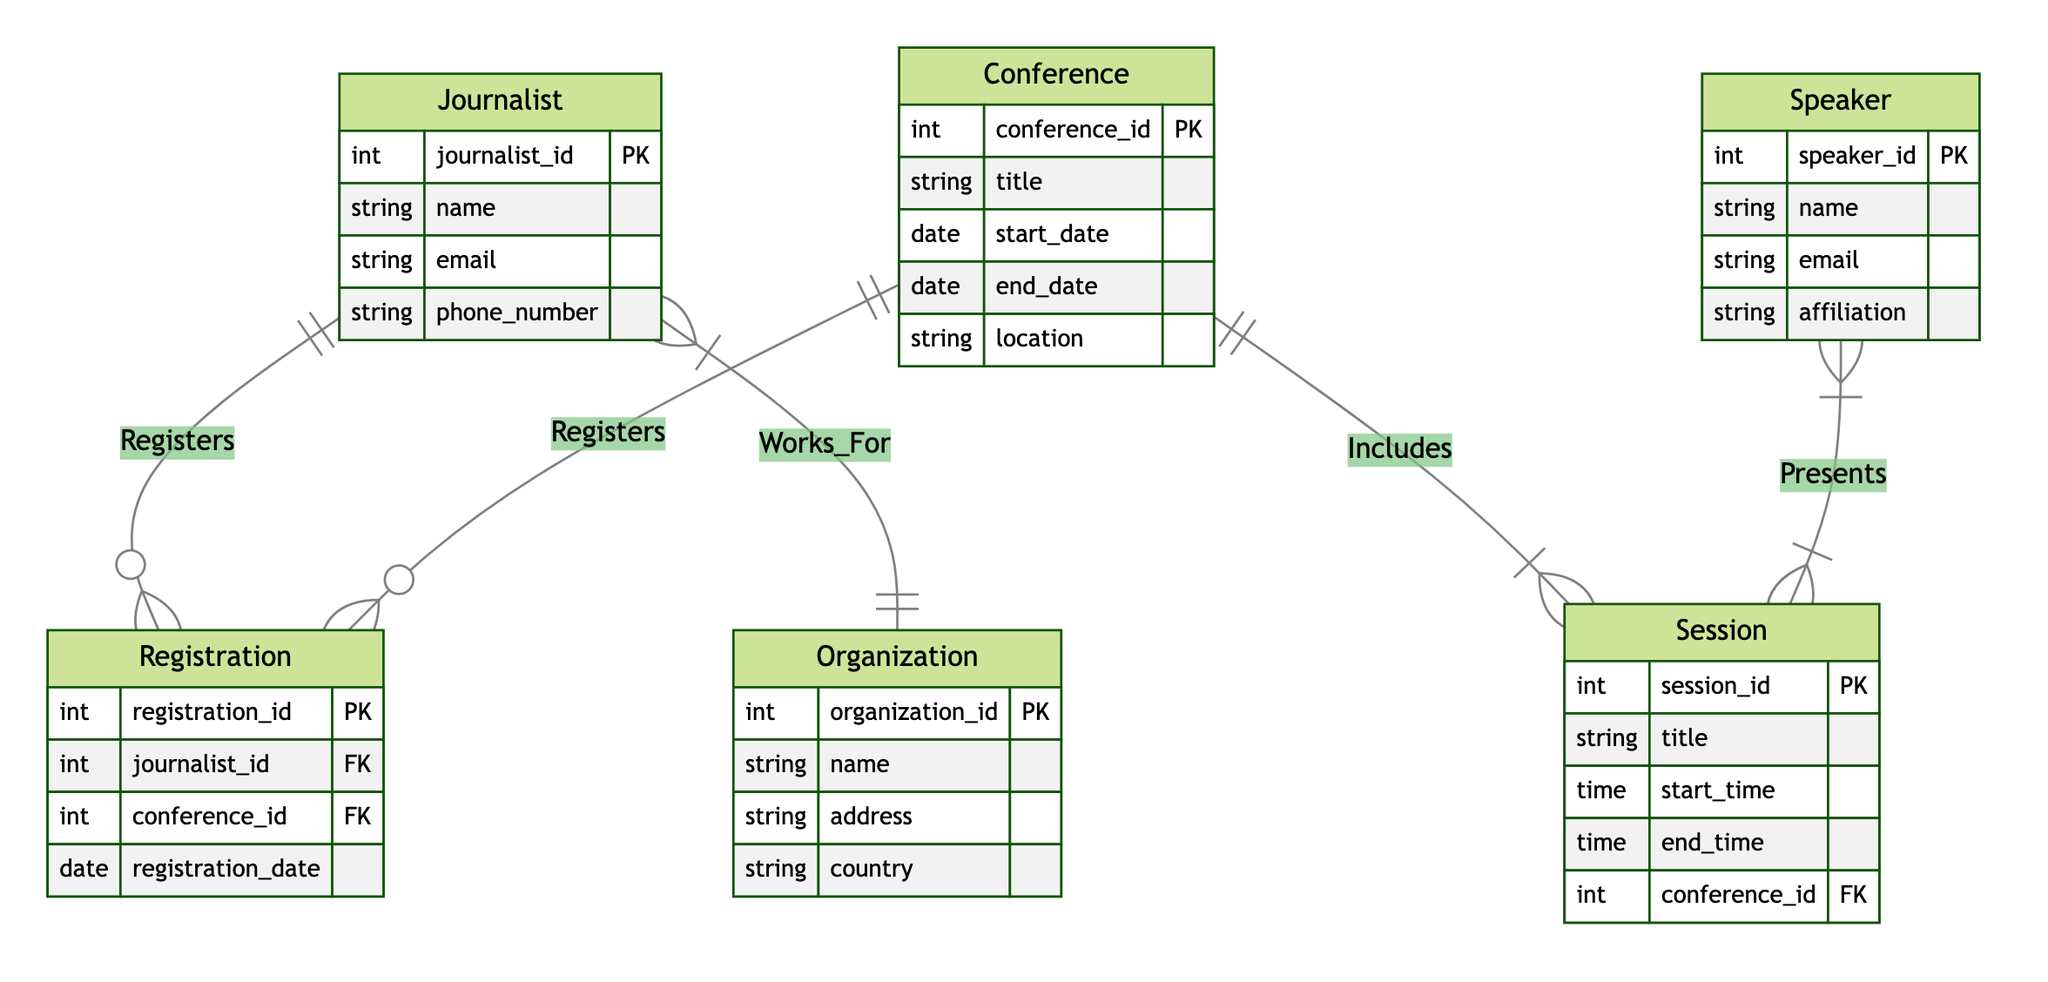What is the primary key of the Journalist entity? The primary key of the Journalist entity is journalist_id, which uniquely identifies each journalist in the system.
Answer: journalist_id How many attributes does the Conference entity have? The Conference entity has five attributes: conference_id, title, start_date, end_date, and location.
Answer: five What relationship exists between the Journalist and Conference entities? The relationship between the Journalist and Conference entities is titled "Registers," and it is a many-to-many relationship, indicating that multiple journalists can register for multiple conferences.
Answer: Registers How many sessions can a Conference include? A Conference can include one or more sessions, as indicated by the one-to-many relationship labeled "Includes" between Conference and Session.
Answer: one or more Which entity is the Speaker associated with in this diagram? The Speaker entity is associated with the Session entity through the "Presents" relationship, which is a many-to-many relationship.
Answer: Session How many organizations can a Journalist work for? A Journalist can work for one organization, as indicated by the one-to-many relationship labeled "Works_For" indicating that multiple journalists may work for the same organization, while each journalist works for only one organization.
Answer: one What is the significance of the "Presents" relationship? The "Presents" relationship signifies that multiple speakers can present at multiple sessions, illustrating a many-to-many interaction between the Speaker and Session entities.
Answer: many-to-many What type of diagram is being used to represent the data? The type of diagram being used is an Entity Relationship Diagram (ERD), specifically designed to show the relationships between various entities in a database context.
Answer: Entity Relationship Diagram 